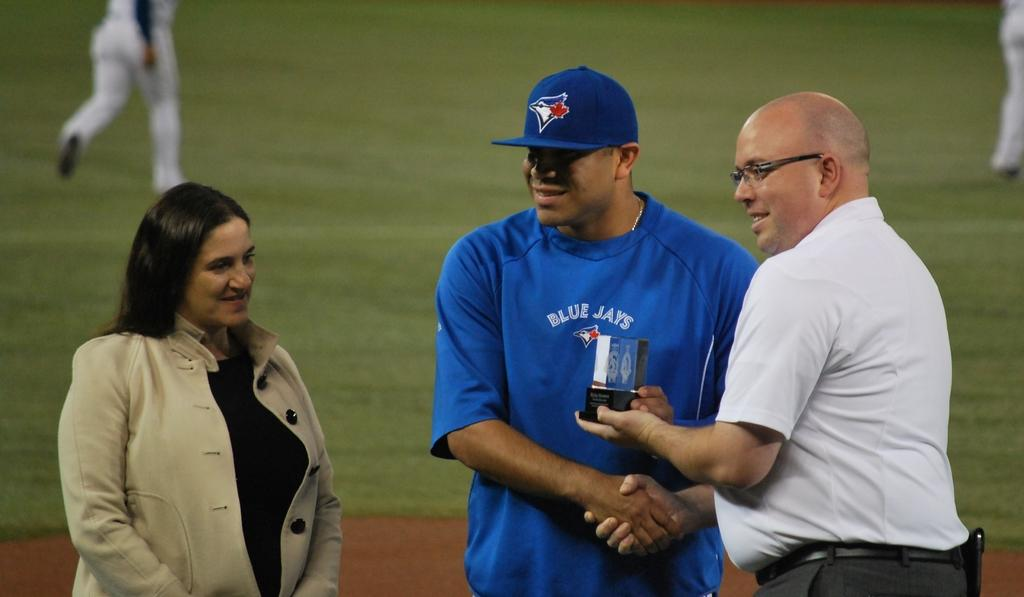<image>
Create a compact narrative representing the image presented. A Blue Jays player is given an award from a man. 